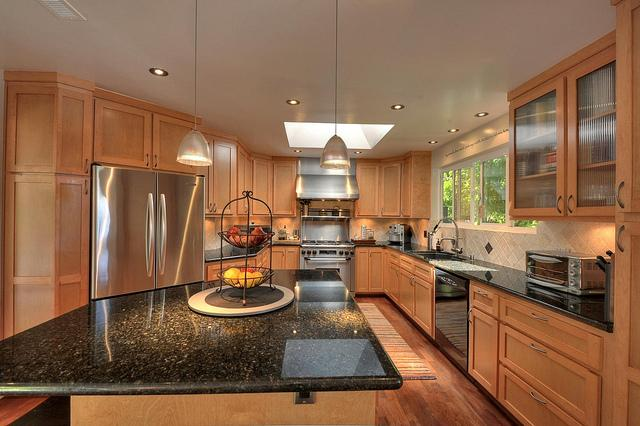What is the countertop in the middle called? island 